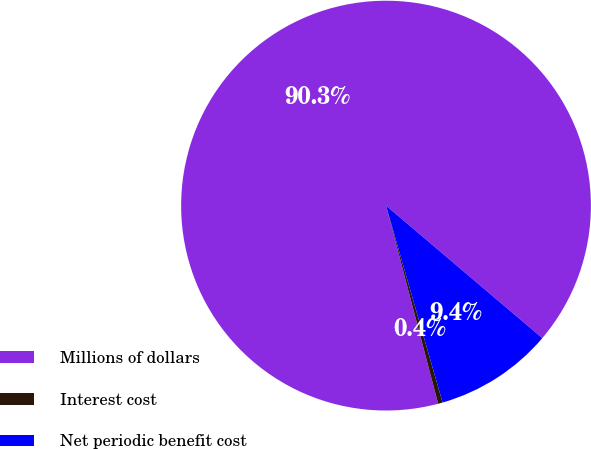Convert chart to OTSL. <chart><loc_0><loc_0><loc_500><loc_500><pie_chart><fcel>Millions of dollars<fcel>Interest cost<fcel>Net periodic benefit cost<nl><fcel>90.29%<fcel>0.36%<fcel>9.35%<nl></chart> 